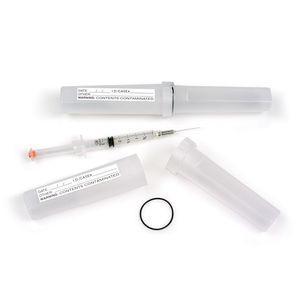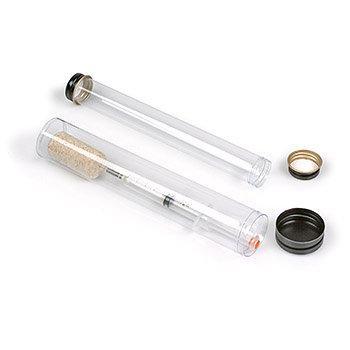The first image is the image on the left, the second image is the image on the right. Given the left and right images, does the statement "An image shows at least three tubes with caps on the ends." hold true? Answer yes or no. No. The first image is the image on the left, the second image is the image on the right. For the images displayed, is the sentence "There are two canisters in the right image." factually correct? Answer yes or no. Yes. 